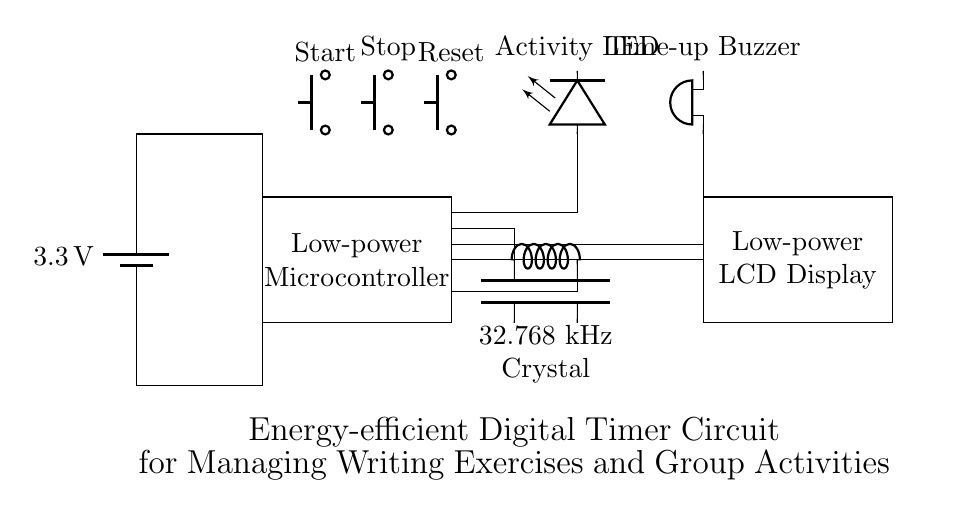What is the output voltage of the power supply? The circuit diagram shows a battery labeled with a voltage of 3.3 volts. This indicates the output voltage supplied to the circuit.
Answer: 3.3 volts What type of display is used in the circuit? The circuit diagram includes a section labeled "Low-power LCD Display," indicating that an LCD (Liquid Crystal Display) is used to show the timer's status or countdown information.
Answer: Low-power LCD Display What component is used to indicate the end of the timer? The section labeled "Time-up Buzzer" indicates that a buzzer is included in the circuit for signaling the completion of the timer.
Answer: Buzzer How many buttons are present in the circuit? The circuit diagram shows three buttons labeled "Start," "Stop," and "Reset." This means there are three buttons designed for user interaction with the timer.
Answer: Three What is the frequency of the crystal oscillator? The circuit diagram displays a crystal labeled "32.768 kHz Crystal," which indicates the frequency at which the oscillator operates, essential for accurate timing.
Answer: 32.768 kHz Why is a low-power microcontroller essential for this circuit? The circuit diagram features a "Low-power Microcontroller," emphasizing the need for energy efficiency. Low-power components minimize energy consumption, making them suitable for prolonged use without excessive power drain.
Answer: Energy efficiency What is the purpose of the "Activity LED" in the circuit? The circuit includes an "Activity LED" that serves as a visual indicator of the ongoing writing exercises or activities. This feedback helps users know when the timer is active and when tasks are in progress.
Answer: Visual indicator 